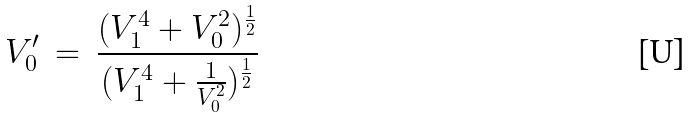Convert formula to latex. <formula><loc_0><loc_0><loc_500><loc_500>V _ { 0 } ^ { \prime } \, = \, \frac { ( V _ { 1 } ^ { 4 } + V _ { 0 } ^ { 2 } ) ^ { \frac { 1 } { 2 } } } { ( V _ { 1 } ^ { 4 } + \frac { 1 } { V _ { 0 } ^ { 2 } } ) ^ { \frac { 1 } { 2 } } }</formula> 